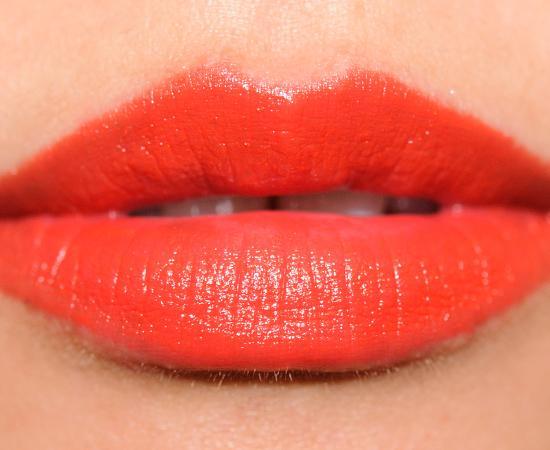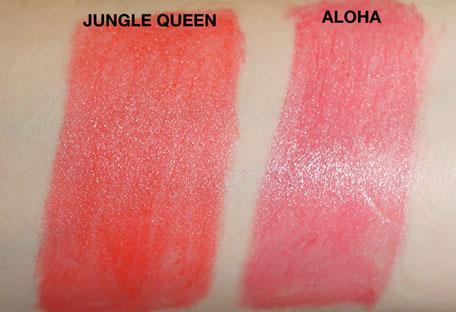The first image is the image on the left, the second image is the image on the right. Evaluate the accuracy of this statement regarding the images: "One image includes tinted lips, and the other shows a color sample on skin.". Is it true? Answer yes or no. Yes. The first image is the image on the left, the second image is the image on the right. Evaluate the accuracy of this statement regarding the images: "There is one lipstick mark across the person's skin on the image on the right.". Is it true? Answer yes or no. No. 